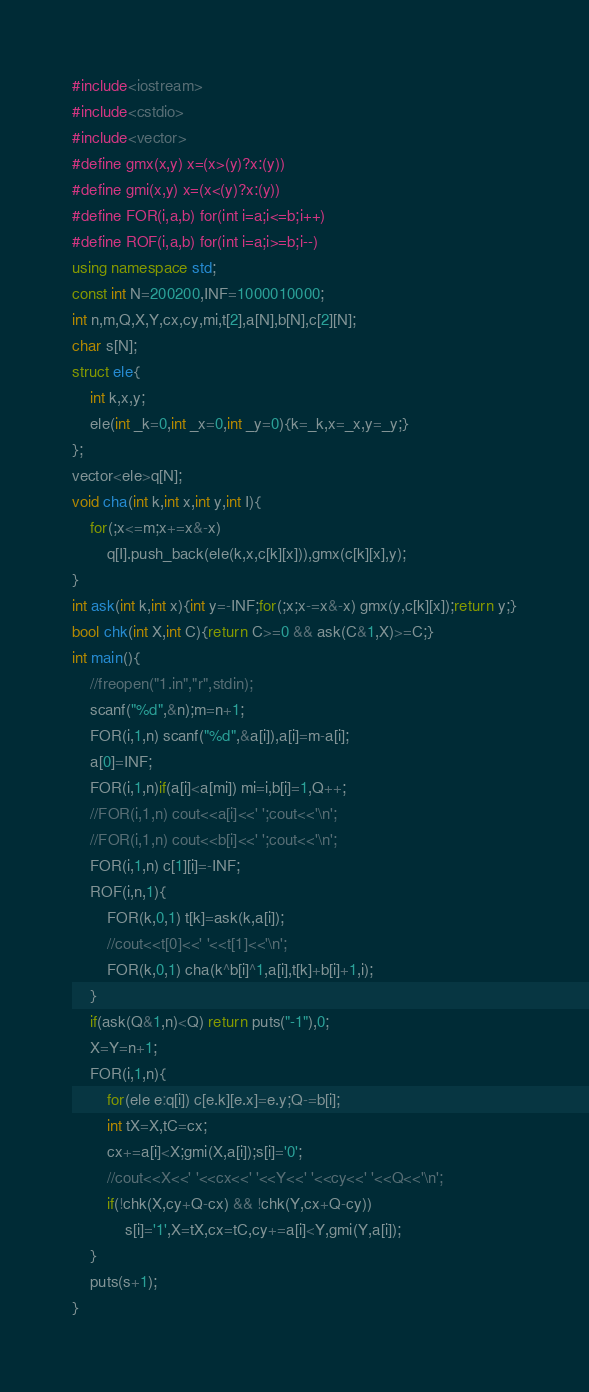<code> <loc_0><loc_0><loc_500><loc_500><_C++_>#include<iostream>
#include<cstdio>
#include<vector>
#define gmx(x,y) x=(x>(y)?x:(y))
#define gmi(x,y) x=(x<(y)?x:(y))
#define FOR(i,a,b) for(int i=a;i<=b;i++)
#define ROF(i,a,b) for(int i=a;i>=b;i--)
using namespace std;
const int N=200200,INF=1000010000;
int n,m,Q,X,Y,cx,cy,mi,t[2],a[N],b[N],c[2][N];
char s[N];
struct ele{
	int k,x,y;
	ele(int _k=0,int _x=0,int _y=0){k=_k,x=_x,y=_y;}
};
vector<ele>q[N];
void cha(int k,int x,int y,int I){
	for(;x<=m;x+=x&-x)
		q[I].push_back(ele(k,x,c[k][x])),gmx(c[k][x],y);
}
int ask(int k,int x){int y=-INF;for(;x;x-=x&-x) gmx(y,c[k][x]);return y;}
bool chk(int X,int C){return C>=0 && ask(C&1,X)>=C;}
int main(){
	//freopen("1.in","r",stdin);
	scanf("%d",&n);m=n+1;
	FOR(i,1,n) scanf("%d",&a[i]),a[i]=m-a[i];
	a[0]=INF;
	FOR(i,1,n)if(a[i]<a[mi]) mi=i,b[i]=1,Q++;
	//FOR(i,1,n) cout<<a[i]<<' ';cout<<'\n';
	//FOR(i,1,n) cout<<b[i]<<' ';cout<<'\n';
	FOR(i,1,n) c[1][i]=-INF;
	ROF(i,n,1){
		FOR(k,0,1) t[k]=ask(k,a[i]);
		//cout<<t[0]<<' '<<t[1]<<'\n';
		FOR(k,0,1) cha(k^b[i]^1,a[i],t[k]+b[i]+1,i);
	}
	if(ask(Q&1,n)<Q) return puts("-1"),0;
	X=Y=n+1;
	FOR(i,1,n){
		for(ele e:q[i]) c[e.k][e.x]=e.y;Q-=b[i];
		int tX=X,tC=cx;
		cx+=a[i]<X;gmi(X,a[i]);s[i]='0';
		//cout<<X<<' '<<cx<<' '<<Y<<' '<<cy<<' '<<Q<<'\n';
		if(!chk(X,cy+Q-cx) && !chk(Y,cx+Q-cy))
			s[i]='1',X=tX,cx=tC,cy+=a[i]<Y,gmi(Y,a[i]);
	}
	puts(s+1);
}</code> 